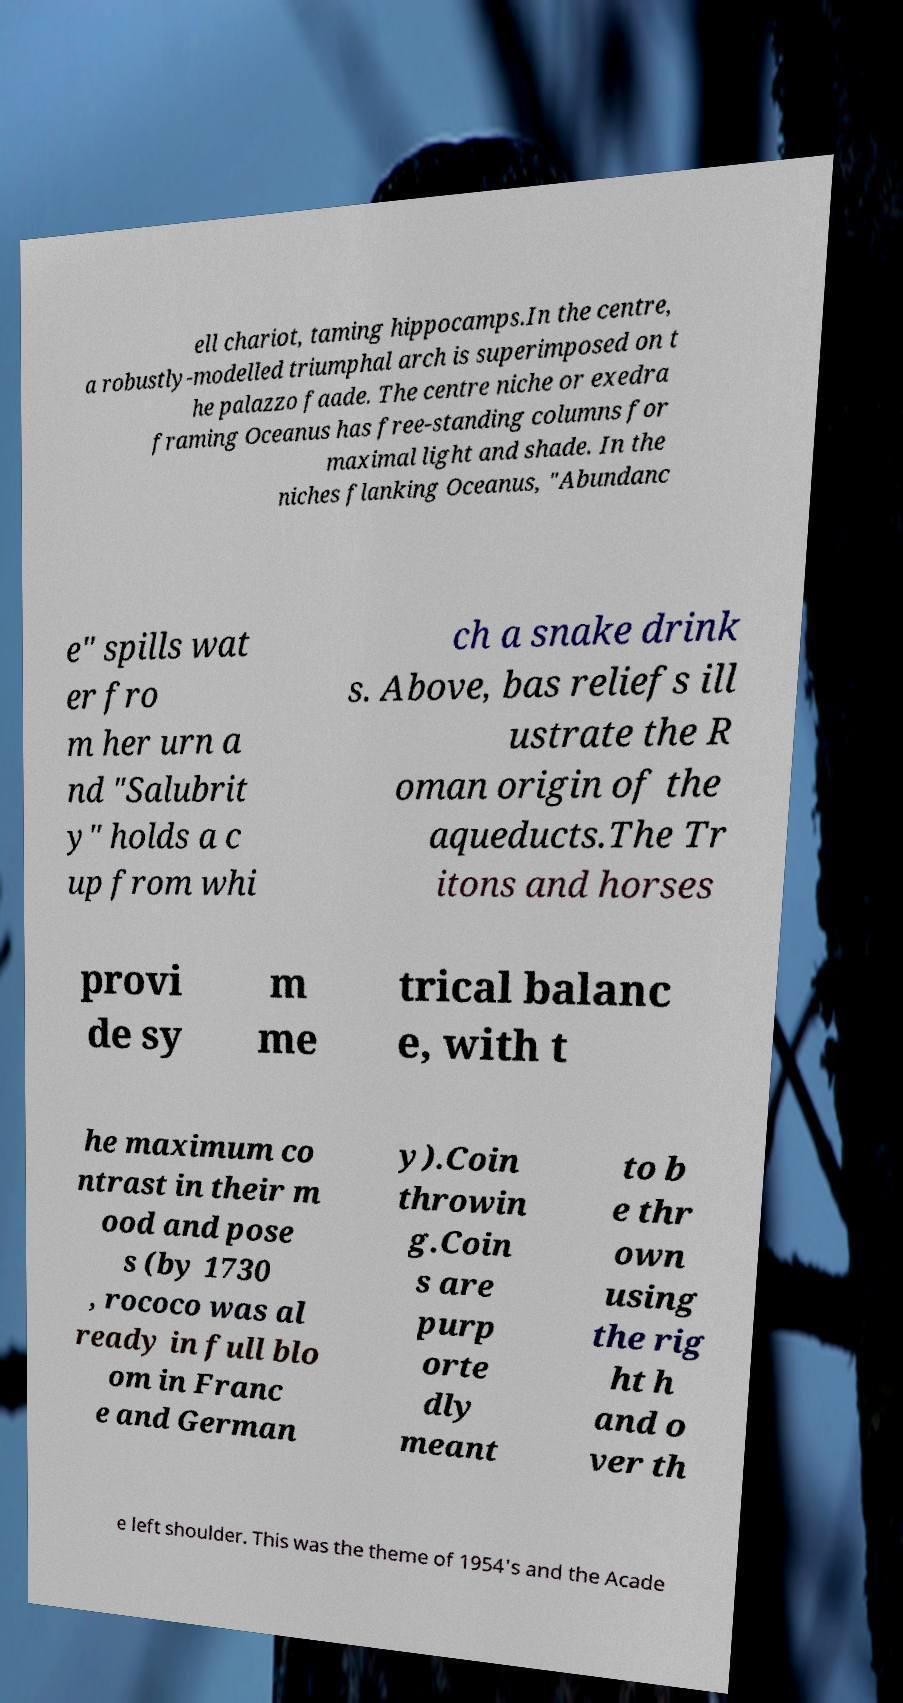Could you extract and type out the text from this image? ell chariot, taming hippocamps.In the centre, a robustly-modelled triumphal arch is superimposed on t he palazzo faade. The centre niche or exedra framing Oceanus has free-standing columns for maximal light and shade. In the niches flanking Oceanus, "Abundanc e" spills wat er fro m her urn a nd "Salubrit y" holds a c up from whi ch a snake drink s. Above, bas reliefs ill ustrate the R oman origin of the aqueducts.The Tr itons and horses provi de sy m me trical balanc e, with t he maximum co ntrast in their m ood and pose s (by 1730 , rococo was al ready in full blo om in Franc e and German y).Coin throwin g.Coin s are purp orte dly meant to b e thr own using the rig ht h and o ver th e left shoulder. This was the theme of 1954's and the Acade 